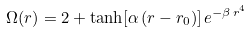<formula> <loc_0><loc_0><loc_500><loc_500>\Omega ( r ) = 2 + \tanh [ \alpha \, ( r - r _ { 0 } ) ] \, e ^ { - \beta \, r ^ { 4 } }</formula> 